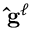Convert formula to latex. <formula><loc_0><loc_0><loc_500><loc_500>\hat { g } ^ { \ell }</formula> 